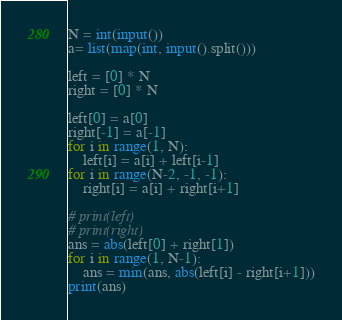<code> <loc_0><loc_0><loc_500><loc_500><_Python_>N = int(input())
a= list(map(int, input().split()))

left = [0] * N
right = [0] * N

left[0] = a[0]
right[-1] = a[-1]
for i in range(1, N):
    left[i] = a[i] + left[i-1]
for i in range(N-2, -1, -1):
    right[i] = a[i] + right[i+1]

# print(left)
# print(right)
ans = abs(left[0] + right[1])
for i in range(1, N-1):
    ans = min(ans, abs(left[i] - right[i+1]))
print(ans)
</code> 